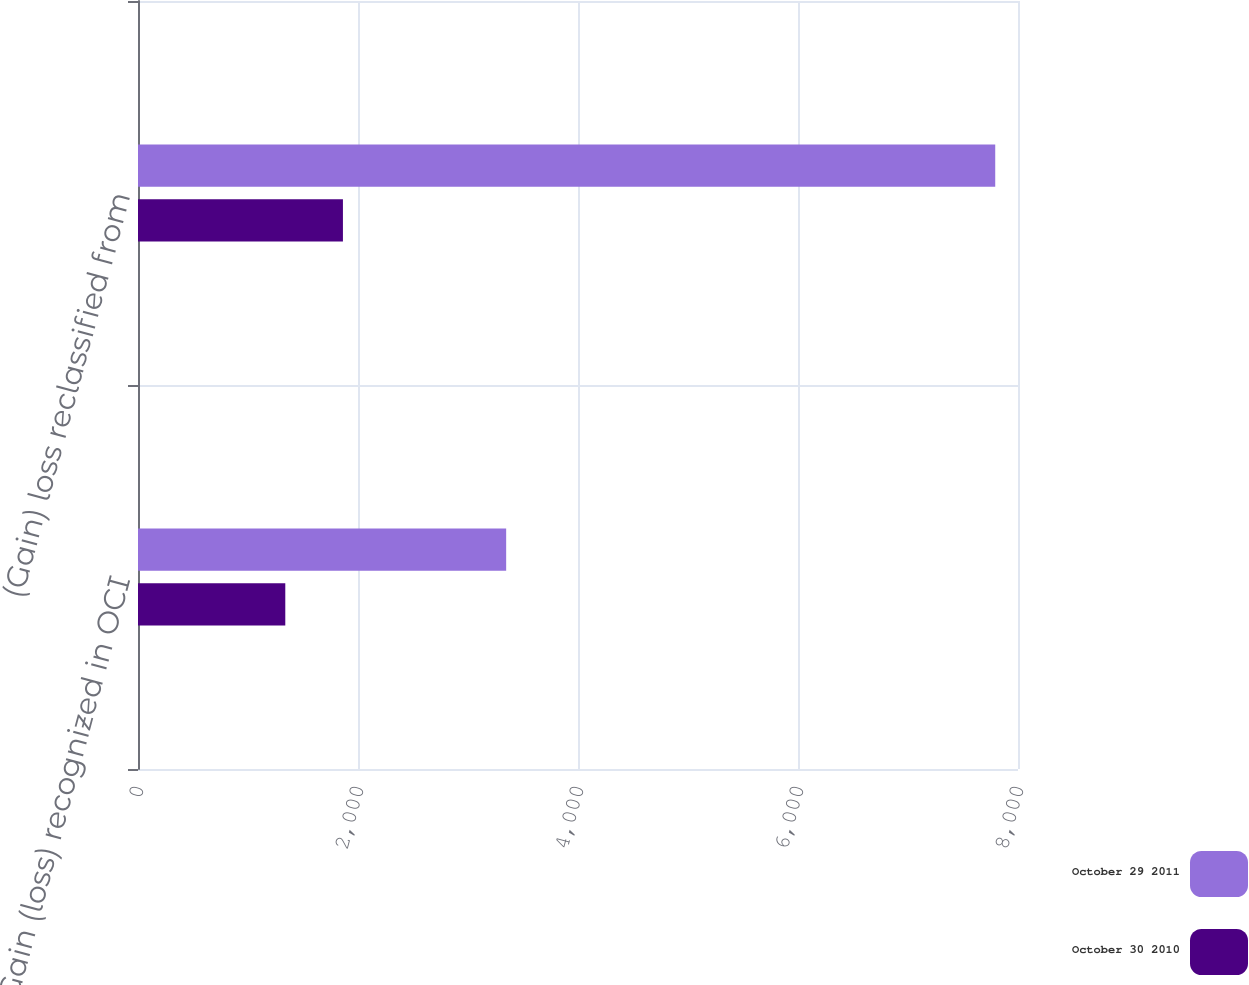<chart> <loc_0><loc_0><loc_500><loc_500><stacked_bar_chart><ecel><fcel>Gain (loss) recognized in OCI<fcel>(Gain) loss reclassified from<nl><fcel>October 29 2011<fcel>3347<fcel>7793<nl><fcel>October 30 2010<fcel>1339<fcel>1863<nl></chart> 